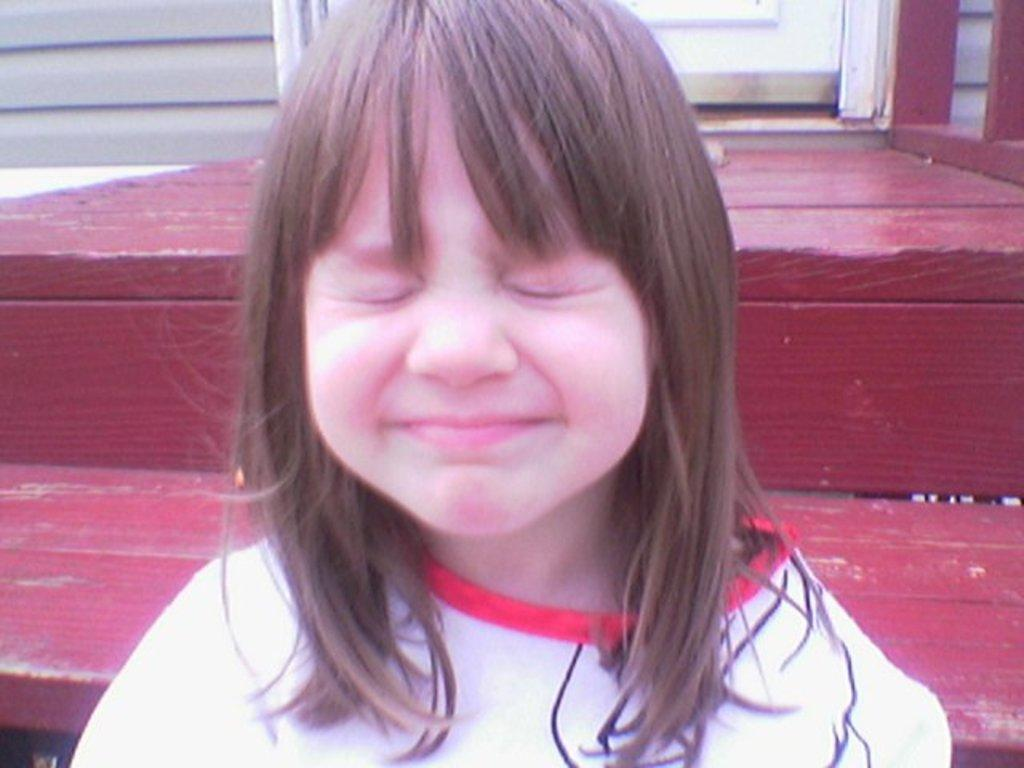What is the main subject of the image? There is a child in the image. What is the child doing in the image? The child is smiling in the image. What is the child's facial expression in the image? The child has closed her eyes in the image. What can be seen in the background of the image? There is a door visible in the background of the image. What book is the child reading in the image? There is no book present in the image, and the child is not reading. 